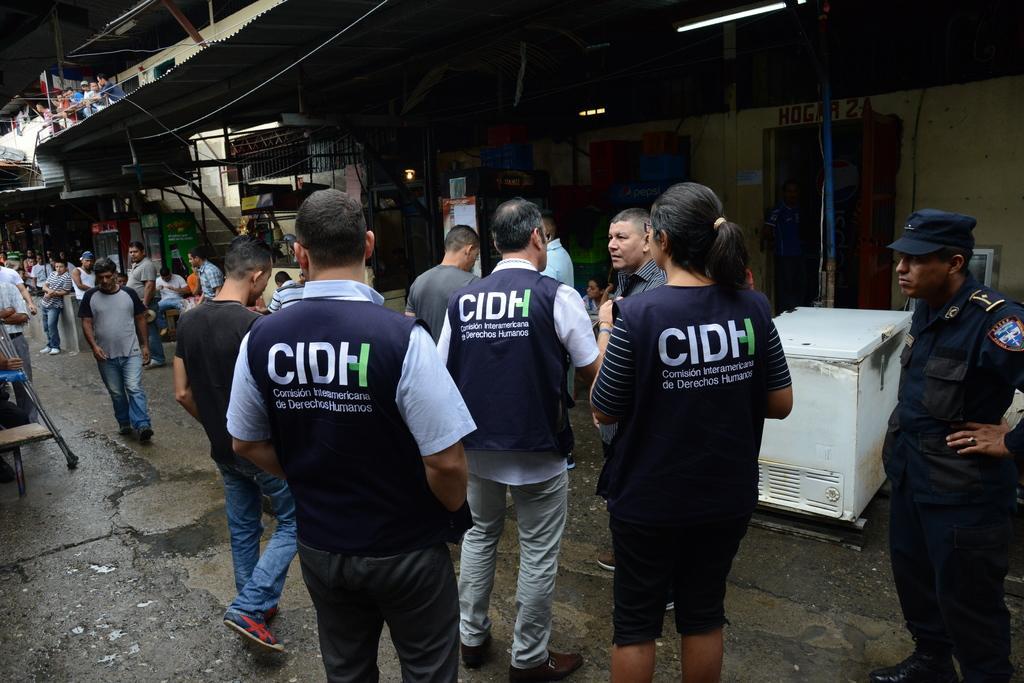How would you summarize this image in a sentence or two? In this image, we can see many people and some are wearing coats. On the right, we can see a person wearing uniform and a cap. In the background, there are sheds and we can see flags, poles, lights, refrigerators and we can see a container and a tv and some other objects and stairs and a wall. At the bottom, there is a floor. 